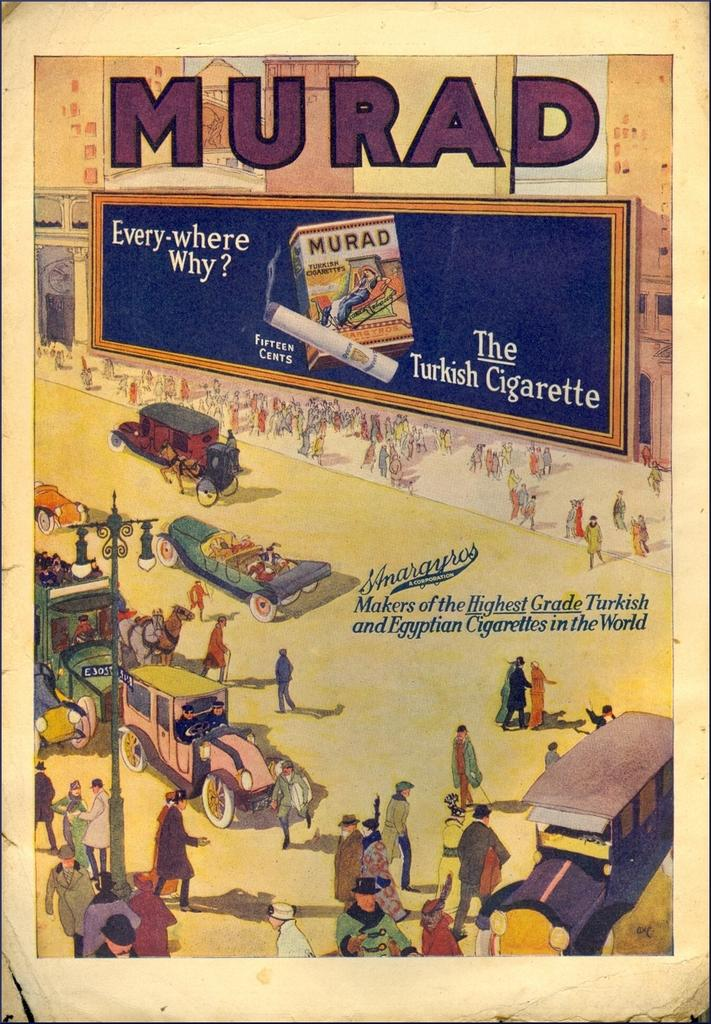<image>
Relay a brief, clear account of the picture shown. An illustrated advertisement indicates that Murad is The Turkish Cigarette. 